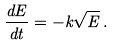<formula> <loc_0><loc_0><loc_500><loc_500>\frac { d E } { d t } = - k \sqrt { E } \, .</formula> 